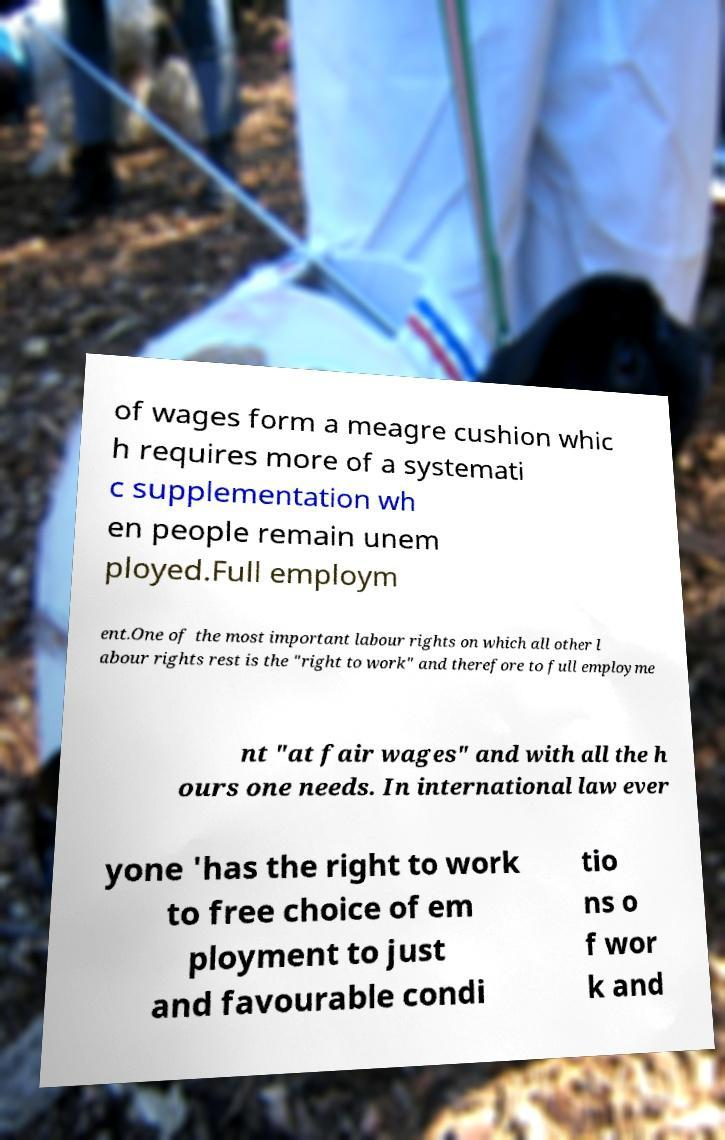I need the written content from this picture converted into text. Can you do that? of wages form a meagre cushion whic h requires more of a systemati c supplementation wh en people remain unem ployed.Full employm ent.One of the most important labour rights on which all other l abour rights rest is the "right to work" and therefore to full employme nt "at fair wages" and with all the h ours one needs. In international law ever yone 'has the right to work to free choice of em ployment to just and favourable condi tio ns o f wor k and 